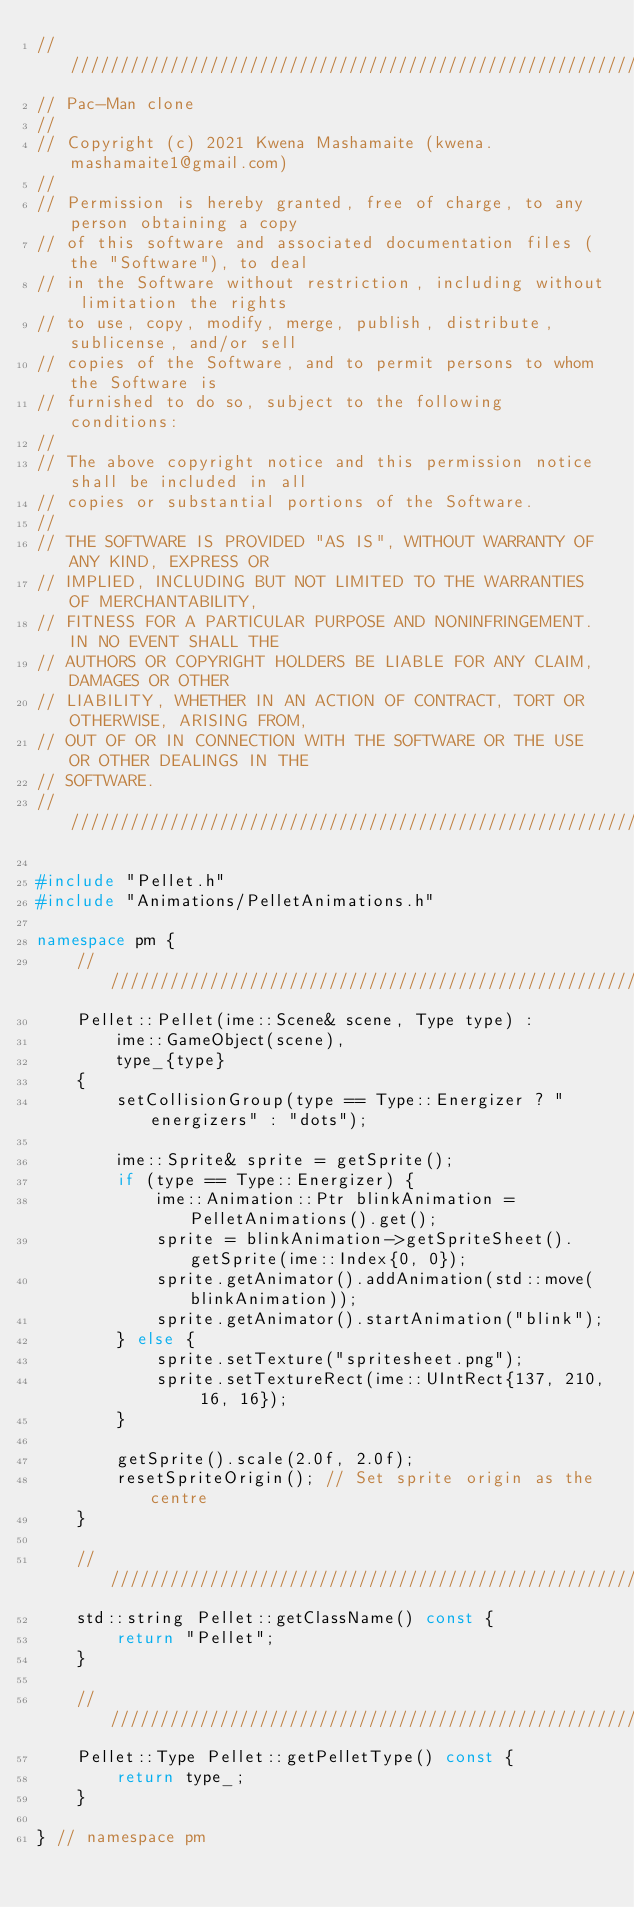<code> <loc_0><loc_0><loc_500><loc_500><_C++_>////////////////////////////////////////////////////////////////////////////////
// Pac-Man clone
//
// Copyright (c) 2021 Kwena Mashamaite (kwena.mashamaite1@gmail.com)
//
// Permission is hereby granted, free of charge, to any person obtaining a copy
// of this software and associated documentation files (the "Software"), to deal
// in the Software without restriction, including without limitation the rights
// to use, copy, modify, merge, publish, distribute, sublicense, and/or sell
// copies of the Software, and to permit persons to whom the Software is
// furnished to do so, subject to the following conditions:
//
// The above copyright notice and this permission notice shall be included in all
// copies or substantial portions of the Software.
//
// THE SOFTWARE IS PROVIDED "AS IS", WITHOUT WARRANTY OF ANY KIND, EXPRESS OR
// IMPLIED, INCLUDING BUT NOT LIMITED TO THE WARRANTIES OF MERCHANTABILITY,
// FITNESS FOR A PARTICULAR PURPOSE AND NONINFRINGEMENT. IN NO EVENT SHALL THE
// AUTHORS OR COPYRIGHT HOLDERS BE LIABLE FOR ANY CLAIM, DAMAGES OR OTHER
// LIABILITY, WHETHER IN AN ACTION OF CONTRACT, TORT OR OTHERWISE, ARISING FROM,
// OUT OF OR IN CONNECTION WITH THE SOFTWARE OR THE USE OR OTHER DEALINGS IN THE
// SOFTWARE.
////////////////////////////////////////////////////////////////////////////////

#include "Pellet.h"
#include "Animations/PelletAnimations.h"

namespace pm {
    ///////////////////////////////////////////////////////////////
    Pellet::Pellet(ime::Scene& scene, Type type) :
        ime::GameObject(scene),
        type_{type}
    {
        setCollisionGroup(type == Type::Energizer ? "energizers" : "dots");

        ime::Sprite& sprite = getSprite();
        if (type == Type::Energizer) {
            ime::Animation::Ptr blinkAnimation = PelletAnimations().get();
            sprite = blinkAnimation->getSpriteSheet().getSprite(ime::Index{0, 0});
            sprite.getAnimator().addAnimation(std::move(blinkAnimation));
            sprite.getAnimator().startAnimation("blink");
        } else {
            sprite.setTexture("spritesheet.png");
            sprite.setTextureRect(ime::UIntRect{137, 210, 16, 16});
        }

        getSprite().scale(2.0f, 2.0f);
        resetSpriteOrigin(); // Set sprite origin as the centre
    }

    ///////////////////////////////////////////////////////////////
    std::string Pellet::getClassName() const {
        return "Pellet";
    }

    ///////////////////////////////////////////////////////////////
    Pellet::Type Pellet::getPelletType() const {
        return type_;
    }

} // namespace pm
</code> 